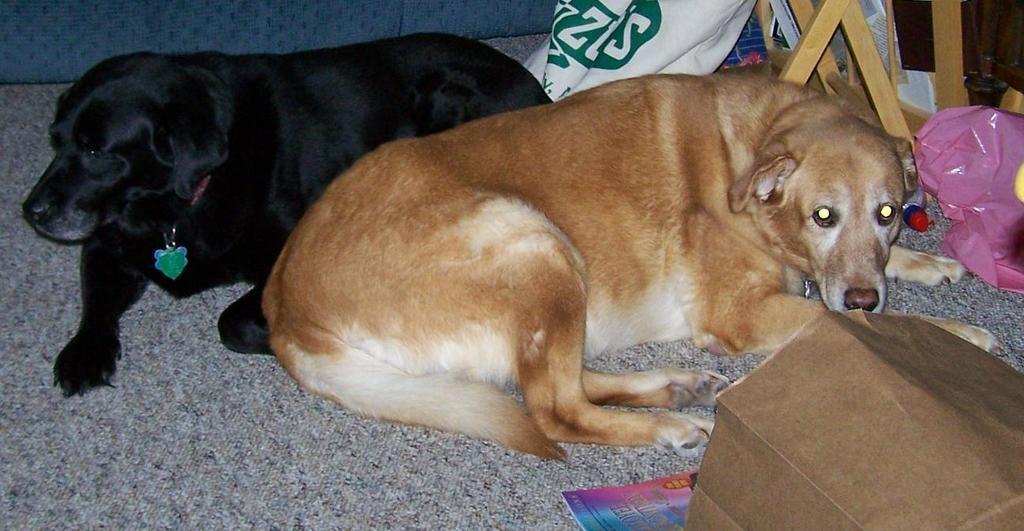Could you give a brief overview of what you see in this image? 2 dogs are sitting on the floor. They are black and brown in color. There are other objects on the floor. 